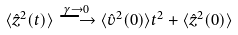Convert formula to latex. <formula><loc_0><loc_0><loc_500><loc_500>\langle { \hat { z } } ^ { 2 } ( t ) \rangle \stackrel { \gamma \to 0 } { \longrightarrow } \langle { \hat { v } } ^ { 2 } ( 0 ) \rangle t ^ { 2 } + \langle { \hat { z } } ^ { 2 } ( 0 ) \rangle</formula> 